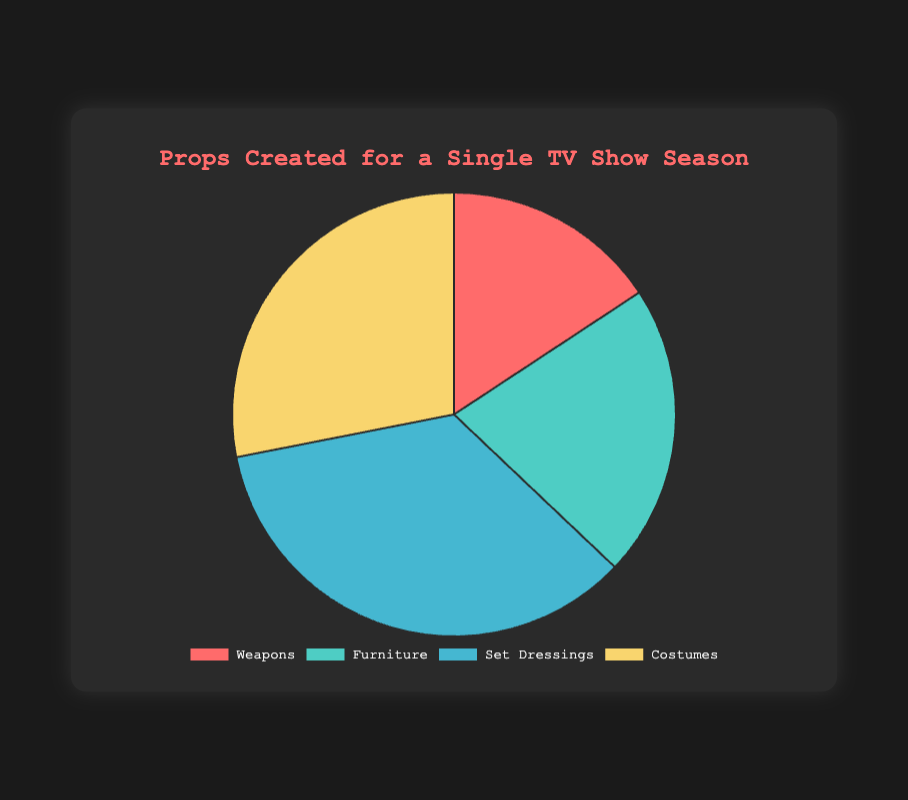What type of prop has the highest total quantity produced? Looking at the pie chart, the section with the largest area corresponds to Set Dressings, which has the highest total quantity produced.
Answer: Set Dressings Which prop category has the smallest total quantity? The smallest section in the pie chart is for Weapons, indicating it has the smallest total quantity produced.
Answer: Weapons How many more Costumes were created compared to Weapons? From the chart, Costumes have 25 items and Weapons have 14 items. The difference is 25 - 14 = 11.
Answer: 11 What is the total quantity of all props created for the TV show season? Sum the total quantities of all categories: 14 (Weapons) + 19 (Furniture) + 31 (Set Dressings) + 25 (Costumes) = 89.
Answer: 89 Are there more Set Dressings or Costumes, and by how much? Set Dressings: 31, Costumes: 25. The difference is 31 - 25 = 6.
Answer: Set Dressings by 6 Which category uses the color green in the pie chart? Observing the colors, Furniture uses the green color in the chart.
Answer: Furniture What percentage of the total props are Weapons? Weapons have 14 of the total 89 props. The percentage is (14 / 89) * 100 ≈ 15.73%.
Answer: ≈ 15.73% If you combine the quantities of Weapons and Costumes, does it exceed the quantity of Set Dressings? Weapons: 14, Costumes: 25. Combined: 14 + 25 = 39, which is greater than Set Dressings at 31.
Answer: Yes What is the difference in total quantity between the highest and lowest categories? Highest: Set Dressings (31), Lowest: Weapons (14). Difference: 31 - 14 = 17.
Answer: 17 